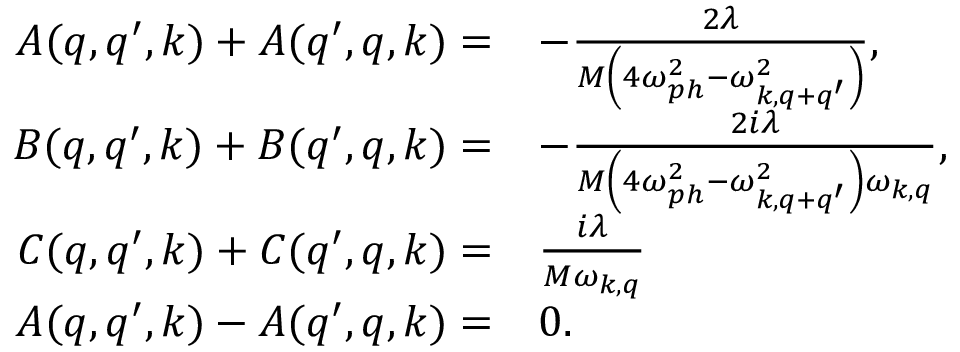<formula> <loc_0><loc_0><loc_500><loc_500>\begin{array} { r l } { A ( q , q ^ { \prime } , k ) + A ( q ^ { \prime } , q , k ) = } & { - \frac { 2 \lambda } { M \left ( 4 \omega _ { p h } ^ { 2 } - \omega _ { k , q + q ^ { \prime } } ^ { 2 } \right ) } , } \\ { B ( q , q ^ { \prime } , k ) + B ( q ^ { \prime } , q , k ) = } & { - \frac { 2 i \lambda } { M \left ( 4 \omega _ { p h } ^ { 2 } - \omega _ { k , q + q ^ { \prime } } ^ { 2 } \right ) \omega _ { k , q } } , } \\ { C ( q , q ^ { \prime } , k ) + C ( q ^ { \prime } , q , k ) = } & { \frac { i \lambda } { M \omega _ { k , q } } } \\ { A ( q , q ^ { \prime } , k ) - A ( q ^ { \prime } , q , k ) = } & { 0 . } \end{array}</formula> 